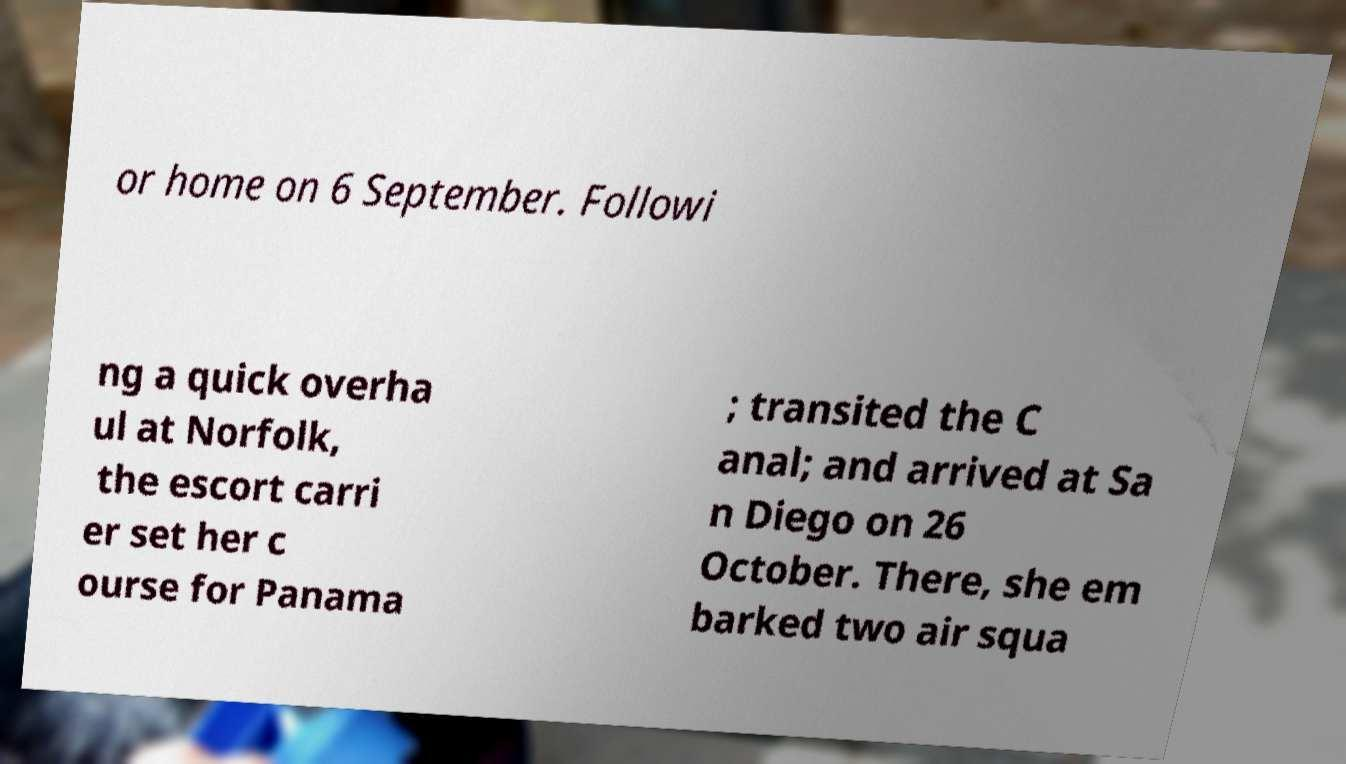Can you accurately transcribe the text from the provided image for me? or home on 6 September. Followi ng a quick overha ul at Norfolk, the escort carri er set her c ourse for Panama ; transited the C anal; and arrived at Sa n Diego on 26 October. There, she em barked two air squa 